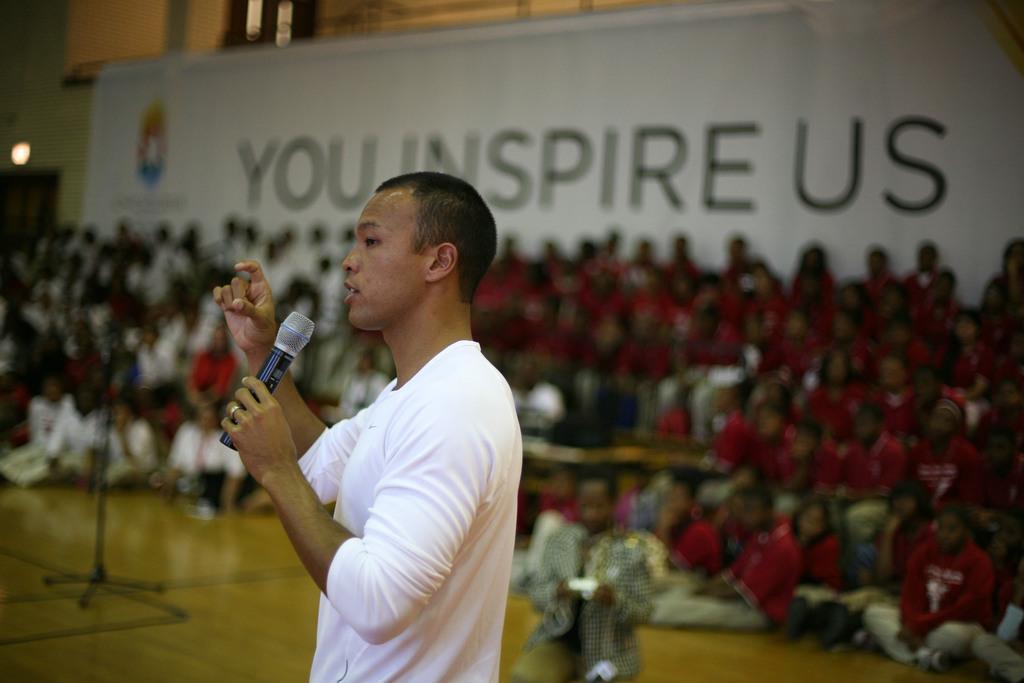Describe this image in one or two sentences. In this image I can see one person is wearing white color dress and holding a mic. Back I can see few people, wall and the white color board. 